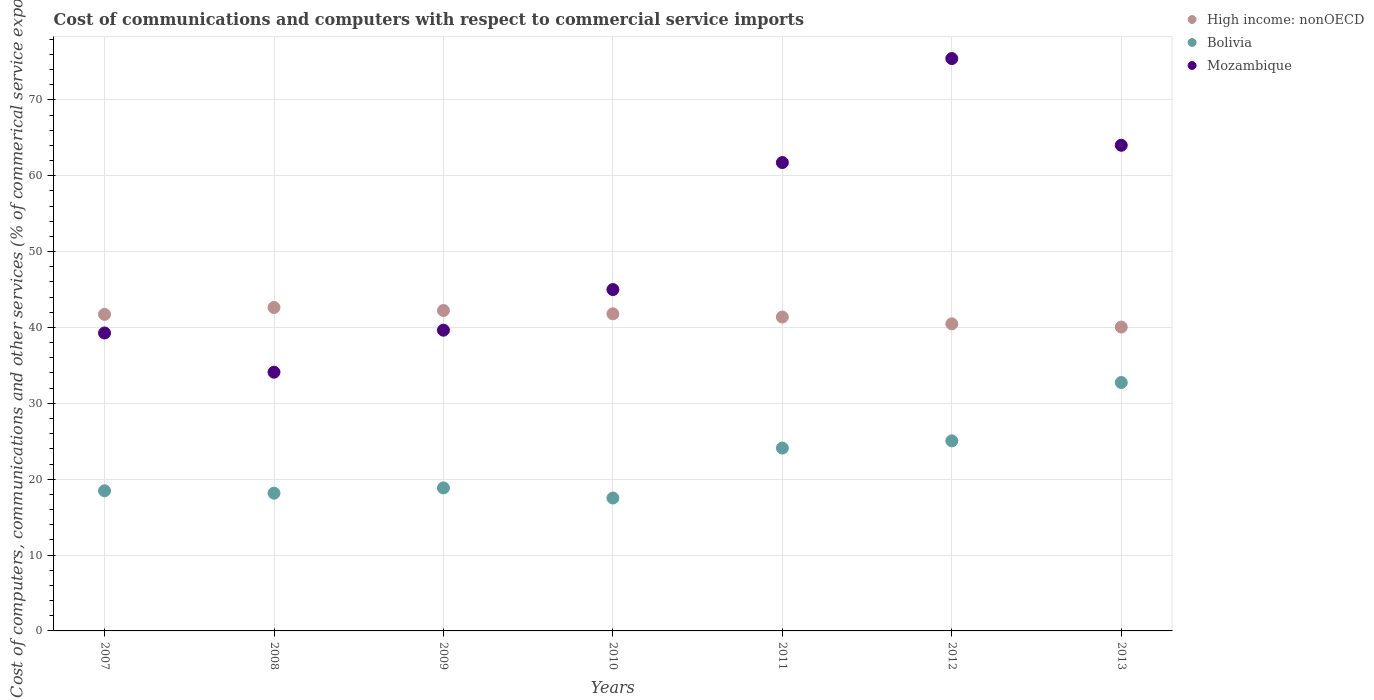How many different coloured dotlines are there?
Your response must be concise. 3. What is the cost of communications and computers in High income: nonOECD in 2013?
Give a very brief answer. 40.06. Across all years, what is the maximum cost of communications and computers in Bolivia?
Make the answer very short. 32.75. Across all years, what is the minimum cost of communications and computers in High income: nonOECD?
Give a very brief answer. 40.06. In which year was the cost of communications and computers in Mozambique maximum?
Provide a succinct answer. 2012. In which year was the cost of communications and computers in Bolivia minimum?
Offer a terse response. 2010. What is the total cost of communications and computers in High income: nonOECD in the graph?
Offer a very short reply. 290.31. What is the difference between the cost of communications and computers in Bolivia in 2007 and that in 2008?
Offer a very short reply. 0.32. What is the difference between the cost of communications and computers in Mozambique in 2007 and the cost of communications and computers in Bolivia in 2009?
Your response must be concise. 20.42. What is the average cost of communications and computers in High income: nonOECD per year?
Your response must be concise. 41.47. In the year 2007, what is the difference between the cost of communications and computers in High income: nonOECD and cost of communications and computers in Bolivia?
Keep it short and to the point. 23.26. What is the ratio of the cost of communications and computers in High income: nonOECD in 2008 to that in 2011?
Ensure brevity in your answer.  1.03. What is the difference between the highest and the second highest cost of communications and computers in High income: nonOECD?
Ensure brevity in your answer.  0.4. What is the difference between the highest and the lowest cost of communications and computers in Bolivia?
Your answer should be very brief. 15.23. Is the sum of the cost of communications and computers in Bolivia in 2008 and 2010 greater than the maximum cost of communications and computers in High income: nonOECD across all years?
Give a very brief answer. No. Does the cost of communications and computers in Bolivia monotonically increase over the years?
Give a very brief answer. No. How many years are there in the graph?
Give a very brief answer. 7. Are the values on the major ticks of Y-axis written in scientific E-notation?
Your response must be concise. No. Does the graph contain any zero values?
Provide a succinct answer. No. Does the graph contain grids?
Make the answer very short. Yes. Where does the legend appear in the graph?
Offer a very short reply. Top right. What is the title of the graph?
Offer a terse response. Cost of communications and computers with respect to commercial service imports. Does "East Asia (developing only)" appear as one of the legend labels in the graph?
Your answer should be compact. No. What is the label or title of the Y-axis?
Your answer should be compact. Cost of computers, communications and other services (% of commerical service exports). What is the Cost of computers, communications and other services (% of commerical service exports) of High income: nonOECD in 2007?
Provide a short and direct response. 41.73. What is the Cost of computers, communications and other services (% of commerical service exports) in Bolivia in 2007?
Offer a terse response. 18.47. What is the Cost of computers, communications and other services (% of commerical service exports) in Mozambique in 2007?
Your response must be concise. 39.27. What is the Cost of computers, communications and other services (% of commerical service exports) in High income: nonOECD in 2008?
Ensure brevity in your answer.  42.63. What is the Cost of computers, communications and other services (% of commerical service exports) in Bolivia in 2008?
Offer a terse response. 18.15. What is the Cost of computers, communications and other services (% of commerical service exports) in Mozambique in 2008?
Offer a terse response. 34.11. What is the Cost of computers, communications and other services (% of commerical service exports) in High income: nonOECD in 2009?
Your answer should be compact. 42.24. What is the Cost of computers, communications and other services (% of commerical service exports) of Bolivia in 2009?
Provide a short and direct response. 18.85. What is the Cost of computers, communications and other services (% of commerical service exports) in Mozambique in 2009?
Give a very brief answer. 39.64. What is the Cost of computers, communications and other services (% of commerical service exports) of High income: nonOECD in 2010?
Provide a short and direct response. 41.8. What is the Cost of computers, communications and other services (% of commerical service exports) in Bolivia in 2010?
Keep it short and to the point. 17.52. What is the Cost of computers, communications and other services (% of commerical service exports) in Mozambique in 2010?
Your response must be concise. 45. What is the Cost of computers, communications and other services (% of commerical service exports) in High income: nonOECD in 2011?
Ensure brevity in your answer.  41.38. What is the Cost of computers, communications and other services (% of commerical service exports) in Bolivia in 2011?
Keep it short and to the point. 24.1. What is the Cost of computers, communications and other services (% of commerical service exports) in Mozambique in 2011?
Make the answer very short. 61.74. What is the Cost of computers, communications and other services (% of commerical service exports) in High income: nonOECD in 2012?
Make the answer very short. 40.48. What is the Cost of computers, communications and other services (% of commerical service exports) in Bolivia in 2012?
Provide a succinct answer. 25.05. What is the Cost of computers, communications and other services (% of commerical service exports) in Mozambique in 2012?
Give a very brief answer. 75.45. What is the Cost of computers, communications and other services (% of commerical service exports) in High income: nonOECD in 2013?
Your response must be concise. 40.06. What is the Cost of computers, communications and other services (% of commerical service exports) of Bolivia in 2013?
Ensure brevity in your answer.  32.75. What is the Cost of computers, communications and other services (% of commerical service exports) of Mozambique in 2013?
Make the answer very short. 64.02. Across all years, what is the maximum Cost of computers, communications and other services (% of commerical service exports) in High income: nonOECD?
Your answer should be compact. 42.63. Across all years, what is the maximum Cost of computers, communications and other services (% of commerical service exports) of Bolivia?
Provide a succinct answer. 32.75. Across all years, what is the maximum Cost of computers, communications and other services (% of commerical service exports) of Mozambique?
Your answer should be compact. 75.45. Across all years, what is the minimum Cost of computers, communications and other services (% of commerical service exports) of High income: nonOECD?
Ensure brevity in your answer.  40.06. Across all years, what is the minimum Cost of computers, communications and other services (% of commerical service exports) in Bolivia?
Your response must be concise. 17.52. Across all years, what is the minimum Cost of computers, communications and other services (% of commerical service exports) of Mozambique?
Keep it short and to the point. 34.11. What is the total Cost of computers, communications and other services (% of commerical service exports) in High income: nonOECD in the graph?
Make the answer very short. 290.31. What is the total Cost of computers, communications and other services (% of commerical service exports) in Bolivia in the graph?
Give a very brief answer. 154.9. What is the total Cost of computers, communications and other services (% of commerical service exports) in Mozambique in the graph?
Ensure brevity in your answer.  359.23. What is the difference between the Cost of computers, communications and other services (% of commerical service exports) of High income: nonOECD in 2007 and that in 2008?
Your answer should be compact. -0.9. What is the difference between the Cost of computers, communications and other services (% of commerical service exports) of Bolivia in 2007 and that in 2008?
Your answer should be compact. 0.32. What is the difference between the Cost of computers, communications and other services (% of commerical service exports) of Mozambique in 2007 and that in 2008?
Offer a terse response. 5.17. What is the difference between the Cost of computers, communications and other services (% of commerical service exports) of High income: nonOECD in 2007 and that in 2009?
Give a very brief answer. -0.5. What is the difference between the Cost of computers, communications and other services (% of commerical service exports) of Bolivia in 2007 and that in 2009?
Your answer should be very brief. -0.38. What is the difference between the Cost of computers, communications and other services (% of commerical service exports) in Mozambique in 2007 and that in 2009?
Offer a terse response. -0.37. What is the difference between the Cost of computers, communications and other services (% of commerical service exports) in High income: nonOECD in 2007 and that in 2010?
Your answer should be very brief. -0.07. What is the difference between the Cost of computers, communications and other services (% of commerical service exports) of Bolivia in 2007 and that in 2010?
Keep it short and to the point. 0.95. What is the difference between the Cost of computers, communications and other services (% of commerical service exports) of Mozambique in 2007 and that in 2010?
Make the answer very short. -5.73. What is the difference between the Cost of computers, communications and other services (% of commerical service exports) of High income: nonOECD in 2007 and that in 2011?
Your answer should be very brief. 0.35. What is the difference between the Cost of computers, communications and other services (% of commerical service exports) of Bolivia in 2007 and that in 2011?
Keep it short and to the point. -5.63. What is the difference between the Cost of computers, communications and other services (% of commerical service exports) of Mozambique in 2007 and that in 2011?
Your answer should be compact. -22.47. What is the difference between the Cost of computers, communications and other services (% of commerical service exports) in High income: nonOECD in 2007 and that in 2012?
Give a very brief answer. 1.25. What is the difference between the Cost of computers, communications and other services (% of commerical service exports) of Bolivia in 2007 and that in 2012?
Your answer should be very brief. -6.58. What is the difference between the Cost of computers, communications and other services (% of commerical service exports) of Mozambique in 2007 and that in 2012?
Provide a short and direct response. -36.18. What is the difference between the Cost of computers, communications and other services (% of commerical service exports) of High income: nonOECD in 2007 and that in 2013?
Your response must be concise. 1.68. What is the difference between the Cost of computers, communications and other services (% of commerical service exports) of Bolivia in 2007 and that in 2013?
Your answer should be compact. -14.27. What is the difference between the Cost of computers, communications and other services (% of commerical service exports) of Mozambique in 2007 and that in 2013?
Offer a very short reply. -24.75. What is the difference between the Cost of computers, communications and other services (% of commerical service exports) of High income: nonOECD in 2008 and that in 2009?
Ensure brevity in your answer.  0.4. What is the difference between the Cost of computers, communications and other services (% of commerical service exports) of Bolivia in 2008 and that in 2009?
Your answer should be very brief. -0.69. What is the difference between the Cost of computers, communications and other services (% of commerical service exports) in Mozambique in 2008 and that in 2009?
Your response must be concise. -5.54. What is the difference between the Cost of computers, communications and other services (% of commerical service exports) in High income: nonOECD in 2008 and that in 2010?
Make the answer very short. 0.83. What is the difference between the Cost of computers, communications and other services (% of commerical service exports) of Bolivia in 2008 and that in 2010?
Give a very brief answer. 0.64. What is the difference between the Cost of computers, communications and other services (% of commerical service exports) of Mozambique in 2008 and that in 2010?
Give a very brief answer. -10.89. What is the difference between the Cost of computers, communications and other services (% of commerical service exports) in High income: nonOECD in 2008 and that in 2011?
Your answer should be very brief. 1.26. What is the difference between the Cost of computers, communications and other services (% of commerical service exports) in Bolivia in 2008 and that in 2011?
Your answer should be very brief. -5.95. What is the difference between the Cost of computers, communications and other services (% of commerical service exports) of Mozambique in 2008 and that in 2011?
Make the answer very short. -27.63. What is the difference between the Cost of computers, communications and other services (% of commerical service exports) in High income: nonOECD in 2008 and that in 2012?
Ensure brevity in your answer.  2.16. What is the difference between the Cost of computers, communications and other services (% of commerical service exports) of Bolivia in 2008 and that in 2012?
Your answer should be very brief. -6.9. What is the difference between the Cost of computers, communications and other services (% of commerical service exports) of Mozambique in 2008 and that in 2012?
Keep it short and to the point. -41.34. What is the difference between the Cost of computers, communications and other services (% of commerical service exports) in High income: nonOECD in 2008 and that in 2013?
Give a very brief answer. 2.58. What is the difference between the Cost of computers, communications and other services (% of commerical service exports) of Bolivia in 2008 and that in 2013?
Offer a terse response. -14.59. What is the difference between the Cost of computers, communications and other services (% of commerical service exports) of Mozambique in 2008 and that in 2013?
Your response must be concise. -29.91. What is the difference between the Cost of computers, communications and other services (% of commerical service exports) in High income: nonOECD in 2009 and that in 2010?
Your answer should be very brief. 0.43. What is the difference between the Cost of computers, communications and other services (% of commerical service exports) in Bolivia in 2009 and that in 2010?
Your answer should be very brief. 1.33. What is the difference between the Cost of computers, communications and other services (% of commerical service exports) of Mozambique in 2009 and that in 2010?
Provide a succinct answer. -5.36. What is the difference between the Cost of computers, communications and other services (% of commerical service exports) of High income: nonOECD in 2009 and that in 2011?
Offer a terse response. 0.86. What is the difference between the Cost of computers, communications and other services (% of commerical service exports) in Bolivia in 2009 and that in 2011?
Your response must be concise. -5.25. What is the difference between the Cost of computers, communications and other services (% of commerical service exports) of Mozambique in 2009 and that in 2011?
Offer a very short reply. -22.1. What is the difference between the Cost of computers, communications and other services (% of commerical service exports) of High income: nonOECD in 2009 and that in 2012?
Your answer should be compact. 1.76. What is the difference between the Cost of computers, communications and other services (% of commerical service exports) of Bolivia in 2009 and that in 2012?
Offer a very short reply. -6.2. What is the difference between the Cost of computers, communications and other services (% of commerical service exports) of Mozambique in 2009 and that in 2012?
Give a very brief answer. -35.81. What is the difference between the Cost of computers, communications and other services (% of commerical service exports) in High income: nonOECD in 2009 and that in 2013?
Provide a short and direct response. 2.18. What is the difference between the Cost of computers, communications and other services (% of commerical service exports) in Bolivia in 2009 and that in 2013?
Provide a succinct answer. -13.9. What is the difference between the Cost of computers, communications and other services (% of commerical service exports) in Mozambique in 2009 and that in 2013?
Your answer should be compact. -24.38. What is the difference between the Cost of computers, communications and other services (% of commerical service exports) in High income: nonOECD in 2010 and that in 2011?
Ensure brevity in your answer.  0.43. What is the difference between the Cost of computers, communications and other services (% of commerical service exports) in Bolivia in 2010 and that in 2011?
Your answer should be compact. -6.58. What is the difference between the Cost of computers, communications and other services (% of commerical service exports) in Mozambique in 2010 and that in 2011?
Keep it short and to the point. -16.74. What is the difference between the Cost of computers, communications and other services (% of commerical service exports) of High income: nonOECD in 2010 and that in 2012?
Offer a very short reply. 1.32. What is the difference between the Cost of computers, communications and other services (% of commerical service exports) in Bolivia in 2010 and that in 2012?
Offer a very short reply. -7.53. What is the difference between the Cost of computers, communications and other services (% of commerical service exports) of Mozambique in 2010 and that in 2012?
Your answer should be very brief. -30.45. What is the difference between the Cost of computers, communications and other services (% of commerical service exports) of High income: nonOECD in 2010 and that in 2013?
Offer a very short reply. 1.75. What is the difference between the Cost of computers, communications and other services (% of commerical service exports) of Bolivia in 2010 and that in 2013?
Provide a short and direct response. -15.23. What is the difference between the Cost of computers, communications and other services (% of commerical service exports) in Mozambique in 2010 and that in 2013?
Ensure brevity in your answer.  -19.02. What is the difference between the Cost of computers, communications and other services (% of commerical service exports) in High income: nonOECD in 2011 and that in 2012?
Keep it short and to the point. 0.9. What is the difference between the Cost of computers, communications and other services (% of commerical service exports) in Bolivia in 2011 and that in 2012?
Offer a very short reply. -0.95. What is the difference between the Cost of computers, communications and other services (% of commerical service exports) in Mozambique in 2011 and that in 2012?
Your answer should be compact. -13.71. What is the difference between the Cost of computers, communications and other services (% of commerical service exports) in High income: nonOECD in 2011 and that in 2013?
Your response must be concise. 1.32. What is the difference between the Cost of computers, communications and other services (% of commerical service exports) of Bolivia in 2011 and that in 2013?
Your answer should be very brief. -8.64. What is the difference between the Cost of computers, communications and other services (% of commerical service exports) in Mozambique in 2011 and that in 2013?
Your answer should be compact. -2.28. What is the difference between the Cost of computers, communications and other services (% of commerical service exports) of High income: nonOECD in 2012 and that in 2013?
Make the answer very short. 0.42. What is the difference between the Cost of computers, communications and other services (% of commerical service exports) of Bolivia in 2012 and that in 2013?
Make the answer very short. -7.69. What is the difference between the Cost of computers, communications and other services (% of commerical service exports) of Mozambique in 2012 and that in 2013?
Keep it short and to the point. 11.43. What is the difference between the Cost of computers, communications and other services (% of commerical service exports) of High income: nonOECD in 2007 and the Cost of computers, communications and other services (% of commerical service exports) of Bolivia in 2008?
Offer a terse response. 23.58. What is the difference between the Cost of computers, communications and other services (% of commerical service exports) of High income: nonOECD in 2007 and the Cost of computers, communications and other services (% of commerical service exports) of Mozambique in 2008?
Offer a very short reply. 7.62. What is the difference between the Cost of computers, communications and other services (% of commerical service exports) of Bolivia in 2007 and the Cost of computers, communications and other services (% of commerical service exports) of Mozambique in 2008?
Your answer should be very brief. -15.63. What is the difference between the Cost of computers, communications and other services (% of commerical service exports) of High income: nonOECD in 2007 and the Cost of computers, communications and other services (% of commerical service exports) of Bolivia in 2009?
Ensure brevity in your answer.  22.88. What is the difference between the Cost of computers, communications and other services (% of commerical service exports) in High income: nonOECD in 2007 and the Cost of computers, communications and other services (% of commerical service exports) in Mozambique in 2009?
Keep it short and to the point. 2.09. What is the difference between the Cost of computers, communications and other services (% of commerical service exports) of Bolivia in 2007 and the Cost of computers, communications and other services (% of commerical service exports) of Mozambique in 2009?
Offer a very short reply. -21.17. What is the difference between the Cost of computers, communications and other services (% of commerical service exports) in High income: nonOECD in 2007 and the Cost of computers, communications and other services (% of commerical service exports) in Bolivia in 2010?
Your response must be concise. 24.21. What is the difference between the Cost of computers, communications and other services (% of commerical service exports) in High income: nonOECD in 2007 and the Cost of computers, communications and other services (% of commerical service exports) in Mozambique in 2010?
Keep it short and to the point. -3.27. What is the difference between the Cost of computers, communications and other services (% of commerical service exports) in Bolivia in 2007 and the Cost of computers, communications and other services (% of commerical service exports) in Mozambique in 2010?
Provide a short and direct response. -26.53. What is the difference between the Cost of computers, communications and other services (% of commerical service exports) in High income: nonOECD in 2007 and the Cost of computers, communications and other services (% of commerical service exports) in Bolivia in 2011?
Provide a succinct answer. 17.63. What is the difference between the Cost of computers, communications and other services (% of commerical service exports) in High income: nonOECD in 2007 and the Cost of computers, communications and other services (% of commerical service exports) in Mozambique in 2011?
Offer a very short reply. -20.01. What is the difference between the Cost of computers, communications and other services (% of commerical service exports) in Bolivia in 2007 and the Cost of computers, communications and other services (% of commerical service exports) in Mozambique in 2011?
Offer a very short reply. -43.27. What is the difference between the Cost of computers, communications and other services (% of commerical service exports) of High income: nonOECD in 2007 and the Cost of computers, communications and other services (% of commerical service exports) of Bolivia in 2012?
Offer a terse response. 16.68. What is the difference between the Cost of computers, communications and other services (% of commerical service exports) in High income: nonOECD in 2007 and the Cost of computers, communications and other services (% of commerical service exports) in Mozambique in 2012?
Give a very brief answer. -33.72. What is the difference between the Cost of computers, communications and other services (% of commerical service exports) of Bolivia in 2007 and the Cost of computers, communications and other services (% of commerical service exports) of Mozambique in 2012?
Provide a succinct answer. -56.98. What is the difference between the Cost of computers, communications and other services (% of commerical service exports) in High income: nonOECD in 2007 and the Cost of computers, communications and other services (% of commerical service exports) in Bolivia in 2013?
Provide a short and direct response. 8.98. What is the difference between the Cost of computers, communications and other services (% of commerical service exports) in High income: nonOECD in 2007 and the Cost of computers, communications and other services (% of commerical service exports) in Mozambique in 2013?
Offer a very short reply. -22.29. What is the difference between the Cost of computers, communications and other services (% of commerical service exports) in Bolivia in 2007 and the Cost of computers, communications and other services (% of commerical service exports) in Mozambique in 2013?
Your response must be concise. -45.55. What is the difference between the Cost of computers, communications and other services (% of commerical service exports) of High income: nonOECD in 2008 and the Cost of computers, communications and other services (% of commerical service exports) of Bolivia in 2009?
Offer a very short reply. 23.78. What is the difference between the Cost of computers, communications and other services (% of commerical service exports) in High income: nonOECD in 2008 and the Cost of computers, communications and other services (% of commerical service exports) in Mozambique in 2009?
Keep it short and to the point. 2.99. What is the difference between the Cost of computers, communications and other services (% of commerical service exports) in Bolivia in 2008 and the Cost of computers, communications and other services (% of commerical service exports) in Mozambique in 2009?
Offer a very short reply. -21.49. What is the difference between the Cost of computers, communications and other services (% of commerical service exports) in High income: nonOECD in 2008 and the Cost of computers, communications and other services (% of commerical service exports) in Bolivia in 2010?
Make the answer very short. 25.11. What is the difference between the Cost of computers, communications and other services (% of commerical service exports) in High income: nonOECD in 2008 and the Cost of computers, communications and other services (% of commerical service exports) in Mozambique in 2010?
Provide a short and direct response. -2.36. What is the difference between the Cost of computers, communications and other services (% of commerical service exports) in Bolivia in 2008 and the Cost of computers, communications and other services (% of commerical service exports) in Mozambique in 2010?
Provide a succinct answer. -26.84. What is the difference between the Cost of computers, communications and other services (% of commerical service exports) in High income: nonOECD in 2008 and the Cost of computers, communications and other services (% of commerical service exports) in Bolivia in 2011?
Provide a short and direct response. 18.53. What is the difference between the Cost of computers, communications and other services (% of commerical service exports) of High income: nonOECD in 2008 and the Cost of computers, communications and other services (% of commerical service exports) of Mozambique in 2011?
Make the answer very short. -19.11. What is the difference between the Cost of computers, communications and other services (% of commerical service exports) of Bolivia in 2008 and the Cost of computers, communications and other services (% of commerical service exports) of Mozambique in 2011?
Provide a short and direct response. -43.59. What is the difference between the Cost of computers, communications and other services (% of commerical service exports) in High income: nonOECD in 2008 and the Cost of computers, communications and other services (% of commerical service exports) in Bolivia in 2012?
Your answer should be compact. 17.58. What is the difference between the Cost of computers, communications and other services (% of commerical service exports) of High income: nonOECD in 2008 and the Cost of computers, communications and other services (% of commerical service exports) of Mozambique in 2012?
Keep it short and to the point. -32.82. What is the difference between the Cost of computers, communications and other services (% of commerical service exports) in Bolivia in 2008 and the Cost of computers, communications and other services (% of commerical service exports) in Mozambique in 2012?
Keep it short and to the point. -57.3. What is the difference between the Cost of computers, communications and other services (% of commerical service exports) of High income: nonOECD in 2008 and the Cost of computers, communications and other services (% of commerical service exports) of Bolivia in 2013?
Give a very brief answer. 9.89. What is the difference between the Cost of computers, communications and other services (% of commerical service exports) in High income: nonOECD in 2008 and the Cost of computers, communications and other services (% of commerical service exports) in Mozambique in 2013?
Your response must be concise. -21.38. What is the difference between the Cost of computers, communications and other services (% of commerical service exports) of Bolivia in 2008 and the Cost of computers, communications and other services (% of commerical service exports) of Mozambique in 2013?
Provide a short and direct response. -45.86. What is the difference between the Cost of computers, communications and other services (% of commerical service exports) of High income: nonOECD in 2009 and the Cost of computers, communications and other services (% of commerical service exports) of Bolivia in 2010?
Ensure brevity in your answer.  24.72. What is the difference between the Cost of computers, communications and other services (% of commerical service exports) of High income: nonOECD in 2009 and the Cost of computers, communications and other services (% of commerical service exports) of Mozambique in 2010?
Offer a terse response. -2.76. What is the difference between the Cost of computers, communications and other services (% of commerical service exports) of Bolivia in 2009 and the Cost of computers, communications and other services (% of commerical service exports) of Mozambique in 2010?
Offer a very short reply. -26.15. What is the difference between the Cost of computers, communications and other services (% of commerical service exports) in High income: nonOECD in 2009 and the Cost of computers, communications and other services (% of commerical service exports) in Bolivia in 2011?
Provide a succinct answer. 18.13. What is the difference between the Cost of computers, communications and other services (% of commerical service exports) of High income: nonOECD in 2009 and the Cost of computers, communications and other services (% of commerical service exports) of Mozambique in 2011?
Your answer should be compact. -19.5. What is the difference between the Cost of computers, communications and other services (% of commerical service exports) in Bolivia in 2009 and the Cost of computers, communications and other services (% of commerical service exports) in Mozambique in 2011?
Give a very brief answer. -42.89. What is the difference between the Cost of computers, communications and other services (% of commerical service exports) in High income: nonOECD in 2009 and the Cost of computers, communications and other services (% of commerical service exports) in Bolivia in 2012?
Provide a short and direct response. 17.18. What is the difference between the Cost of computers, communications and other services (% of commerical service exports) in High income: nonOECD in 2009 and the Cost of computers, communications and other services (% of commerical service exports) in Mozambique in 2012?
Provide a short and direct response. -33.21. What is the difference between the Cost of computers, communications and other services (% of commerical service exports) in Bolivia in 2009 and the Cost of computers, communications and other services (% of commerical service exports) in Mozambique in 2012?
Your answer should be very brief. -56.6. What is the difference between the Cost of computers, communications and other services (% of commerical service exports) of High income: nonOECD in 2009 and the Cost of computers, communications and other services (% of commerical service exports) of Bolivia in 2013?
Provide a short and direct response. 9.49. What is the difference between the Cost of computers, communications and other services (% of commerical service exports) in High income: nonOECD in 2009 and the Cost of computers, communications and other services (% of commerical service exports) in Mozambique in 2013?
Provide a succinct answer. -21.78. What is the difference between the Cost of computers, communications and other services (% of commerical service exports) in Bolivia in 2009 and the Cost of computers, communications and other services (% of commerical service exports) in Mozambique in 2013?
Your answer should be compact. -45.17. What is the difference between the Cost of computers, communications and other services (% of commerical service exports) of High income: nonOECD in 2010 and the Cost of computers, communications and other services (% of commerical service exports) of Bolivia in 2011?
Keep it short and to the point. 17.7. What is the difference between the Cost of computers, communications and other services (% of commerical service exports) of High income: nonOECD in 2010 and the Cost of computers, communications and other services (% of commerical service exports) of Mozambique in 2011?
Your answer should be compact. -19.94. What is the difference between the Cost of computers, communications and other services (% of commerical service exports) of Bolivia in 2010 and the Cost of computers, communications and other services (% of commerical service exports) of Mozambique in 2011?
Offer a very short reply. -44.22. What is the difference between the Cost of computers, communications and other services (% of commerical service exports) of High income: nonOECD in 2010 and the Cost of computers, communications and other services (% of commerical service exports) of Bolivia in 2012?
Your answer should be very brief. 16.75. What is the difference between the Cost of computers, communications and other services (% of commerical service exports) of High income: nonOECD in 2010 and the Cost of computers, communications and other services (% of commerical service exports) of Mozambique in 2012?
Keep it short and to the point. -33.65. What is the difference between the Cost of computers, communications and other services (% of commerical service exports) in Bolivia in 2010 and the Cost of computers, communications and other services (% of commerical service exports) in Mozambique in 2012?
Ensure brevity in your answer.  -57.93. What is the difference between the Cost of computers, communications and other services (% of commerical service exports) in High income: nonOECD in 2010 and the Cost of computers, communications and other services (% of commerical service exports) in Bolivia in 2013?
Provide a succinct answer. 9.06. What is the difference between the Cost of computers, communications and other services (% of commerical service exports) of High income: nonOECD in 2010 and the Cost of computers, communications and other services (% of commerical service exports) of Mozambique in 2013?
Offer a terse response. -22.22. What is the difference between the Cost of computers, communications and other services (% of commerical service exports) of Bolivia in 2010 and the Cost of computers, communications and other services (% of commerical service exports) of Mozambique in 2013?
Keep it short and to the point. -46.5. What is the difference between the Cost of computers, communications and other services (% of commerical service exports) in High income: nonOECD in 2011 and the Cost of computers, communications and other services (% of commerical service exports) in Bolivia in 2012?
Your response must be concise. 16.32. What is the difference between the Cost of computers, communications and other services (% of commerical service exports) in High income: nonOECD in 2011 and the Cost of computers, communications and other services (% of commerical service exports) in Mozambique in 2012?
Give a very brief answer. -34.07. What is the difference between the Cost of computers, communications and other services (% of commerical service exports) of Bolivia in 2011 and the Cost of computers, communications and other services (% of commerical service exports) of Mozambique in 2012?
Offer a very short reply. -51.35. What is the difference between the Cost of computers, communications and other services (% of commerical service exports) in High income: nonOECD in 2011 and the Cost of computers, communications and other services (% of commerical service exports) in Bolivia in 2013?
Your answer should be very brief. 8.63. What is the difference between the Cost of computers, communications and other services (% of commerical service exports) of High income: nonOECD in 2011 and the Cost of computers, communications and other services (% of commerical service exports) of Mozambique in 2013?
Offer a very short reply. -22.64. What is the difference between the Cost of computers, communications and other services (% of commerical service exports) of Bolivia in 2011 and the Cost of computers, communications and other services (% of commerical service exports) of Mozambique in 2013?
Offer a very short reply. -39.92. What is the difference between the Cost of computers, communications and other services (% of commerical service exports) of High income: nonOECD in 2012 and the Cost of computers, communications and other services (% of commerical service exports) of Bolivia in 2013?
Provide a succinct answer. 7.73. What is the difference between the Cost of computers, communications and other services (% of commerical service exports) in High income: nonOECD in 2012 and the Cost of computers, communications and other services (% of commerical service exports) in Mozambique in 2013?
Offer a terse response. -23.54. What is the difference between the Cost of computers, communications and other services (% of commerical service exports) of Bolivia in 2012 and the Cost of computers, communications and other services (% of commerical service exports) of Mozambique in 2013?
Offer a terse response. -38.97. What is the average Cost of computers, communications and other services (% of commerical service exports) in High income: nonOECD per year?
Give a very brief answer. 41.47. What is the average Cost of computers, communications and other services (% of commerical service exports) of Bolivia per year?
Provide a succinct answer. 22.13. What is the average Cost of computers, communications and other services (% of commerical service exports) in Mozambique per year?
Provide a short and direct response. 51.32. In the year 2007, what is the difference between the Cost of computers, communications and other services (% of commerical service exports) in High income: nonOECD and Cost of computers, communications and other services (% of commerical service exports) in Bolivia?
Your answer should be very brief. 23.26. In the year 2007, what is the difference between the Cost of computers, communications and other services (% of commerical service exports) of High income: nonOECD and Cost of computers, communications and other services (% of commerical service exports) of Mozambique?
Make the answer very short. 2.46. In the year 2007, what is the difference between the Cost of computers, communications and other services (% of commerical service exports) of Bolivia and Cost of computers, communications and other services (% of commerical service exports) of Mozambique?
Offer a very short reply. -20.8. In the year 2008, what is the difference between the Cost of computers, communications and other services (% of commerical service exports) of High income: nonOECD and Cost of computers, communications and other services (% of commerical service exports) of Bolivia?
Offer a very short reply. 24.48. In the year 2008, what is the difference between the Cost of computers, communications and other services (% of commerical service exports) in High income: nonOECD and Cost of computers, communications and other services (% of commerical service exports) in Mozambique?
Give a very brief answer. 8.53. In the year 2008, what is the difference between the Cost of computers, communications and other services (% of commerical service exports) in Bolivia and Cost of computers, communications and other services (% of commerical service exports) in Mozambique?
Your answer should be very brief. -15.95. In the year 2009, what is the difference between the Cost of computers, communications and other services (% of commerical service exports) in High income: nonOECD and Cost of computers, communications and other services (% of commerical service exports) in Bolivia?
Give a very brief answer. 23.39. In the year 2009, what is the difference between the Cost of computers, communications and other services (% of commerical service exports) of High income: nonOECD and Cost of computers, communications and other services (% of commerical service exports) of Mozambique?
Your response must be concise. 2.59. In the year 2009, what is the difference between the Cost of computers, communications and other services (% of commerical service exports) of Bolivia and Cost of computers, communications and other services (% of commerical service exports) of Mozambique?
Provide a short and direct response. -20.79. In the year 2010, what is the difference between the Cost of computers, communications and other services (% of commerical service exports) of High income: nonOECD and Cost of computers, communications and other services (% of commerical service exports) of Bolivia?
Your answer should be very brief. 24.28. In the year 2010, what is the difference between the Cost of computers, communications and other services (% of commerical service exports) in High income: nonOECD and Cost of computers, communications and other services (% of commerical service exports) in Mozambique?
Provide a succinct answer. -3.2. In the year 2010, what is the difference between the Cost of computers, communications and other services (% of commerical service exports) in Bolivia and Cost of computers, communications and other services (% of commerical service exports) in Mozambique?
Offer a very short reply. -27.48. In the year 2011, what is the difference between the Cost of computers, communications and other services (% of commerical service exports) in High income: nonOECD and Cost of computers, communications and other services (% of commerical service exports) in Bolivia?
Make the answer very short. 17.27. In the year 2011, what is the difference between the Cost of computers, communications and other services (% of commerical service exports) of High income: nonOECD and Cost of computers, communications and other services (% of commerical service exports) of Mozambique?
Give a very brief answer. -20.36. In the year 2011, what is the difference between the Cost of computers, communications and other services (% of commerical service exports) of Bolivia and Cost of computers, communications and other services (% of commerical service exports) of Mozambique?
Provide a short and direct response. -37.64. In the year 2012, what is the difference between the Cost of computers, communications and other services (% of commerical service exports) in High income: nonOECD and Cost of computers, communications and other services (% of commerical service exports) in Bolivia?
Your response must be concise. 15.43. In the year 2012, what is the difference between the Cost of computers, communications and other services (% of commerical service exports) of High income: nonOECD and Cost of computers, communications and other services (% of commerical service exports) of Mozambique?
Provide a succinct answer. -34.97. In the year 2012, what is the difference between the Cost of computers, communications and other services (% of commerical service exports) of Bolivia and Cost of computers, communications and other services (% of commerical service exports) of Mozambique?
Make the answer very short. -50.4. In the year 2013, what is the difference between the Cost of computers, communications and other services (% of commerical service exports) in High income: nonOECD and Cost of computers, communications and other services (% of commerical service exports) in Bolivia?
Offer a very short reply. 7.31. In the year 2013, what is the difference between the Cost of computers, communications and other services (% of commerical service exports) of High income: nonOECD and Cost of computers, communications and other services (% of commerical service exports) of Mozambique?
Provide a short and direct response. -23.96. In the year 2013, what is the difference between the Cost of computers, communications and other services (% of commerical service exports) of Bolivia and Cost of computers, communications and other services (% of commerical service exports) of Mozambique?
Ensure brevity in your answer.  -31.27. What is the ratio of the Cost of computers, communications and other services (% of commerical service exports) in High income: nonOECD in 2007 to that in 2008?
Make the answer very short. 0.98. What is the ratio of the Cost of computers, communications and other services (% of commerical service exports) of Bolivia in 2007 to that in 2008?
Provide a short and direct response. 1.02. What is the ratio of the Cost of computers, communications and other services (% of commerical service exports) of Mozambique in 2007 to that in 2008?
Your answer should be compact. 1.15. What is the ratio of the Cost of computers, communications and other services (% of commerical service exports) of High income: nonOECD in 2007 to that in 2009?
Provide a short and direct response. 0.99. What is the ratio of the Cost of computers, communications and other services (% of commerical service exports) of Bolivia in 2007 to that in 2009?
Your response must be concise. 0.98. What is the ratio of the Cost of computers, communications and other services (% of commerical service exports) of Bolivia in 2007 to that in 2010?
Your response must be concise. 1.05. What is the ratio of the Cost of computers, communications and other services (% of commerical service exports) in Mozambique in 2007 to that in 2010?
Your response must be concise. 0.87. What is the ratio of the Cost of computers, communications and other services (% of commerical service exports) of High income: nonOECD in 2007 to that in 2011?
Your response must be concise. 1.01. What is the ratio of the Cost of computers, communications and other services (% of commerical service exports) of Bolivia in 2007 to that in 2011?
Provide a succinct answer. 0.77. What is the ratio of the Cost of computers, communications and other services (% of commerical service exports) in Mozambique in 2007 to that in 2011?
Give a very brief answer. 0.64. What is the ratio of the Cost of computers, communications and other services (% of commerical service exports) in High income: nonOECD in 2007 to that in 2012?
Offer a very short reply. 1.03. What is the ratio of the Cost of computers, communications and other services (% of commerical service exports) of Bolivia in 2007 to that in 2012?
Your response must be concise. 0.74. What is the ratio of the Cost of computers, communications and other services (% of commerical service exports) in Mozambique in 2007 to that in 2012?
Your response must be concise. 0.52. What is the ratio of the Cost of computers, communications and other services (% of commerical service exports) in High income: nonOECD in 2007 to that in 2013?
Offer a terse response. 1.04. What is the ratio of the Cost of computers, communications and other services (% of commerical service exports) of Bolivia in 2007 to that in 2013?
Offer a very short reply. 0.56. What is the ratio of the Cost of computers, communications and other services (% of commerical service exports) in Mozambique in 2007 to that in 2013?
Offer a terse response. 0.61. What is the ratio of the Cost of computers, communications and other services (% of commerical service exports) of High income: nonOECD in 2008 to that in 2009?
Your answer should be very brief. 1.01. What is the ratio of the Cost of computers, communications and other services (% of commerical service exports) of Bolivia in 2008 to that in 2009?
Make the answer very short. 0.96. What is the ratio of the Cost of computers, communications and other services (% of commerical service exports) in Mozambique in 2008 to that in 2009?
Ensure brevity in your answer.  0.86. What is the ratio of the Cost of computers, communications and other services (% of commerical service exports) of High income: nonOECD in 2008 to that in 2010?
Make the answer very short. 1.02. What is the ratio of the Cost of computers, communications and other services (% of commerical service exports) in Bolivia in 2008 to that in 2010?
Provide a short and direct response. 1.04. What is the ratio of the Cost of computers, communications and other services (% of commerical service exports) of Mozambique in 2008 to that in 2010?
Offer a terse response. 0.76. What is the ratio of the Cost of computers, communications and other services (% of commerical service exports) of High income: nonOECD in 2008 to that in 2011?
Provide a succinct answer. 1.03. What is the ratio of the Cost of computers, communications and other services (% of commerical service exports) in Bolivia in 2008 to that in 2011?
Your answer should be very brief. 0.75. What is the ratio of the Cost of computers, communications and other services (% of commerical service exports) of Mozambique in 2008 to that in 2011?
Your response must be concise. 0.55. What is the ratio of the Cost of computers, communications and other services (% of commerical service exports) of High income: nonOECD in 2008 to that in 2012?
Offer a very short reply. 1.05. What is the ratio of the Cost of computers, communications and other services (% of commerical service exports) of Bolivia in 2008 to that in 2012?
Ensure brevity in your answer.  0.72. What is the ratio of the Cost of computers, communications and other services (% of commerical service exports) in Mozambique in 2008 to that in 2012?
Provide a succinct answer. 0.45. What is the ratio of the Cost of computers, communications and other services (% of commerical service exports) of High income: nonOECD in 2008 to that in 2013?
Offer a very short reply. 1.06. What is the ratio of the Cost of computers, communications and other services (% of commerical service exports) in Bolivia in 2008 to that in 2013?
Your answer should be very brief. 0.55. What is the ratio of the Cost of computers, communications and other services (% of commerical service exports) in Mozambique in 2008 to that in 2013?
Offer a very short reply. 0.53. What is the ratio of the Cost of computers, communications and other services (% of commerical service exports) of High income: nonOECD in 2009 to that in 2010?
Your answer should be compact. 1.01. What is the ratio of the Cost of computers, communications and other services (% of commerical service exports) in Bolivia in 2009 to that in 2010?
Keep it short and to the point. 1.08. What is the ratio of the Cost of computers, communications and other services (% of commerical service exports) of Mozambique in 2009 to that in 2010?
Make the answer very short. 0.88. What is the ratio of the Cost of computers, communications and other services (% of commerical service exports) of High income: nonOECD in 2009 to that in 2011?
Ensure brevity in your answer.  1.02. What is the ratio of the Cost of computers, communications and other services (% of commerical service exports) in Bolivia in 2009 to that in 2011?
Your answer should be compact. 0.78. What is the ratio of the Cost of computers, communications and other services (% of commerical service exports) of Mozambique in 2009 to that in 2011?
Your answer should be compact. 0.64. What is the ratio of the Cost of computers, communications and other services (% of commerical service exports) in High income: nonOECD in 2009 to that in 2012?
Make the answer very short. 1.04. What is the ratio of the Cost of computers, communications and other services (% of commerical service exports) in Bolivia in 2009 to that in 2012?
Ensure brevity in your answer.  0.75. What is the ratio of the Cost of computers, communications and other services (% of commerical service exports) in Mozambique in 2009 to that in 2012?
Provide a succinct answer. 0.53. What is the ratio of the Cost of computers, communications and other services (% of commerical service exports) of High income: nonOECD in 2009 to that in 2013?
Give a very brief answer. 1.05. What is the ratio of the Cost of computers, communications and other services (% of commerical service exports) in Bolivia in 2009 to that in 2013?
Your answer should be very brief. 0.58. What is the ratio of the Cost of computers, communications and other services (% of commerical service exports) of Mozambique in 2009 to that in 2013?
Give a very brief answer. 0.62. What is the ratio of the Cost of computers, communications and other services (% of commerical service exports) in High income: nonOECD in 2010 to that in 2011?
Offer a very short reply. 1.01. What is the ratio of the Cost of computers, communications and other services (% of commerical service exports) of Bolivia in 2010 to that in 2011?
Your answer should be compact. 0.73. What is the ratio of the Cost of computers, communications and other services (% of commerical service exports) in Mozambique in 2010 to that in 2011?
Your answer should be compact. 0.73. What is the ratio of the Cost of computers, communications and other services (% of commerical service exports) of High income: nonOECD in 2010 to that in 2012?
Provide a succinct answer. 1.03. What is the ratio of the Cost of computers, communications and other services (% of commerical service exports) in Bolivia in 2010 to that in 2012?
Make the answer very short. 0.7. What is the ratio of the Cost of computers, communications and other services (% of commerical service exports) in Mozambique in 2010 to that in 2012?
Offer a very short reply. 0.6. What is the ratio of the Cost of computers, communications and other services (% of commerical service exports) of High income: nonOECD in 2010 to that in 2013?
Give a very brief answer. 1.04. What is the ratio of the Cost of computers, communications and other services (% of commerical service exports) of Bolivia in 2010 to that in 2013?
Give a very brief answer. 0.54. What is the ratio of the Cost of computers, communications and other services (% of commerical service exports) of Mozambique in 2010 to that in 2013?
Offer a very short reply. 0.7. What is the ratio of the Cost of computers, communications and other services (% of commerical service exports) in High income: nonOECD in 2011 to that in 2012?
Keep it short and to the point. 1.02. What is the ratio of the Cost of computers, communications and other services (% of commerical service exports) of Bolivia in 2011 to that in 2012?
Your answer should be compact. 0.96. What is the ratio of the Cost of computers, communications and other services (% of commerical service exports) in Mozambique in 2011 to that in 2012?
Provide a succinct answer. 0.82. What is the ratio of the Cost of computers, communications and other services (% of commerical service exports) in High income: nonOECD in 2011 to that in 2013?
Offer a terse response. 1.03. What is the ratio of the Cost of computers, communications and other services (% of commerical service exports) of Bolivia in 2011 to that in 2013?
Provide a succinct answer. 0.74. What is the ratio of the Cost of computers, communications and other services (% of commerical service exports) of Mozambique in 2011 to that in 2013?
Provide a short and direct response. 0.96. What is the ratio of the Cost of computers, communications and other services (% of commerical service exports) in High income: nonOECD in 2012 to that in 2013?
Ensure brevity in your answer.  1.01. What is the ratio of the Cost of computers, communications and other services (% of commerical service exports) of Bolivia in 2012 to that in 2013?
Ensure brevity in your answer.  0.77. What is the ratio of the Cost of computers, communications and other services (% of commerical service exports) in Mozambique in 2012 to that in 2013?
Provide a succinct answer. 1.18. What is the difference between the highest and the second highest Cost of computers, communications and other services (% of commerical service exports) of High income: nonOECD?
Ensure brevity in your answer.  0.4. What is the difference between the highest and the second highest Cost of computers, communications and other services (% of commerical service exports) of Bolivia?
Offer a terse response. 7.69. What is the difference between the highest and the second highest Cost of computers, communications and other services (% of commerical service exports) of Mozambique?
Give a very brief answer. 11.43. What is the difference between the highest and the lowest Cost of computers, communications and other services (% of commerical service exports) in High income: nonOECD?
Offer a terse response. 2.58. What is the difference between the highest and the lowest Cost of computers, communications and other services (% of commerical service exports) of Bolivia?
Your answer should be very brief. 15.23. What is the difference between the highest and the lowest Cost of computers, communications and other services (% of commerical service exports) of Mozambique?
Provide a succinct answer. 41.34. 